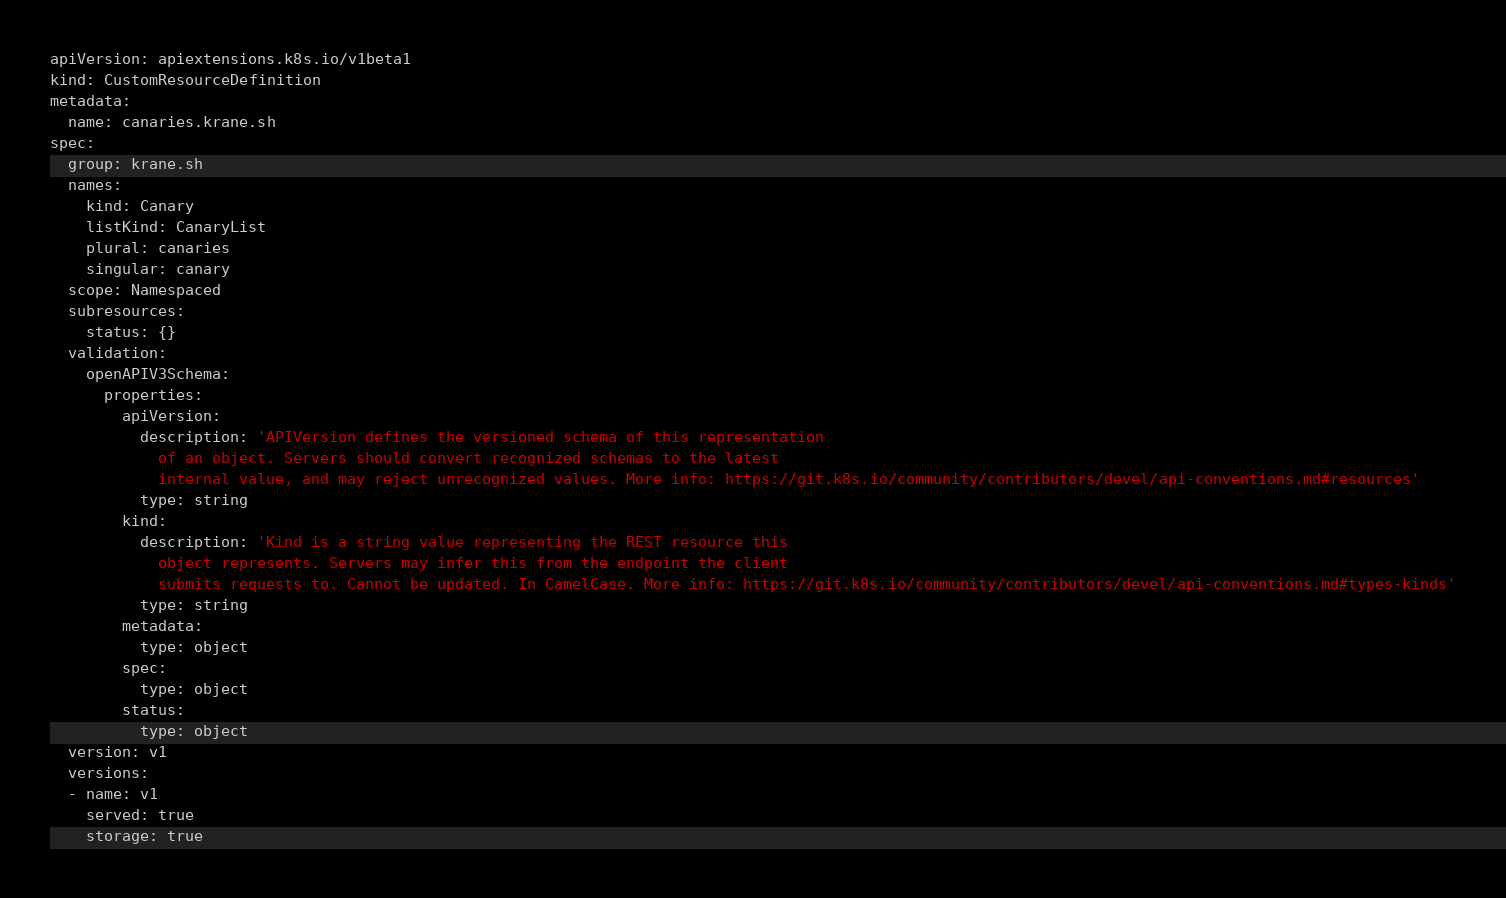Convert code to text. <code><loc_0><loc_0><loc_500><loc_500><_YAML_>apiVersion: apiextensions.k8s.io/v1beta1
kind: CustomResourceDefinition
metadata:
  name: canaries.krane.sh
spec:
  group: krane.sh
  names:
    kind: Canary
    listKind: CanaryList
    plural: canaries
    singular: canary
  scope: Namespaced
  subresources:
    status: {}
  validation:
    openAPIV3Schema:
      properties:
        apiVersion:
          description: 'APIVersion defines the versioned schema of this representation
            of an object. Servers should convert recognized schemas to the latest
            internal value, and may reject unrecognized values. More info: https://git.k8s.io/community/contributors/devel/api-conventions.md#resources'
          type: string
        kind:
          description: 'Kind is a string value representing the REST resource this
            object represents. Servers may infer this from the endpoint the client
            submits requests to. Cannot be updated. In CamelCase. More info: https://git.k8s.io/community/contributors/devel/api-conventions.md#types-kinds'
          type: string
        metadata:
          type: object
        spec:
          type: object
        status:
          type: object
  version: v1
  versions:
  - name: v1
    served: true
    storage: true
</code> 